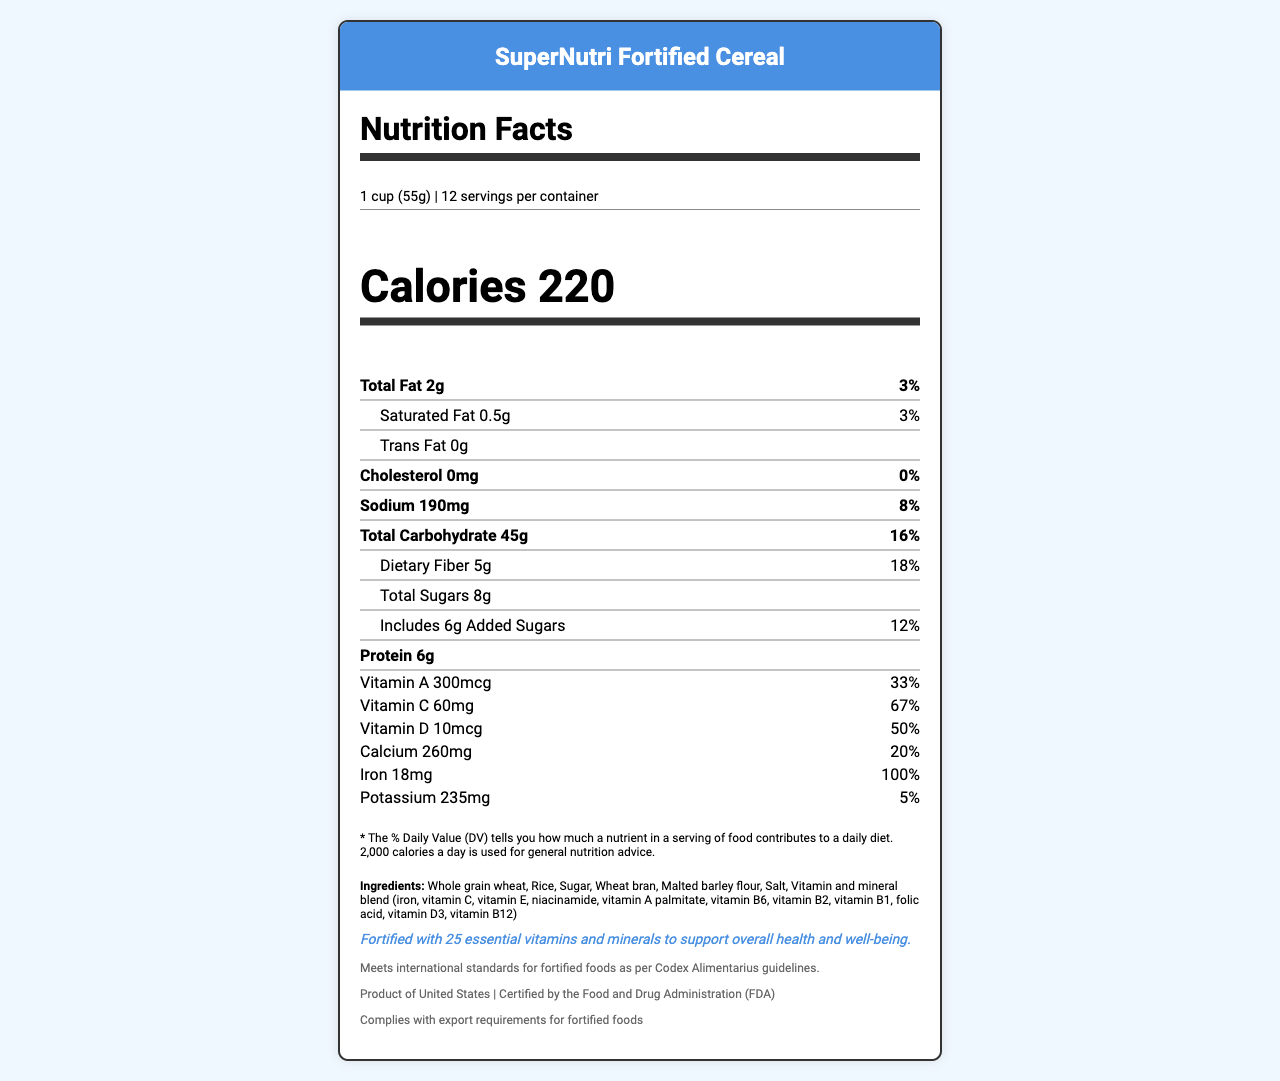what is the serving size? The document specifies the serving size as "1 cup (55g)" in the serving information section.
Answer: 1 cup (55g) how many calories are in one serving? The document lists the calories per serving as 220 in the calories section.
Answer: 220 what is the percentage of daily value for dietary fiber? The document lists the daily value percentage for dietary fiber as 18%.
Answer: 18% what amount of sodium is in one serving? The document specifies the amount of sodium per serving as 190mg.
Answer: 190mg how much iron is in the product, and what is its percent daily value? The document lists the amount of iron as 18mg and the percent daily value as 100%.
Answer: 18mg, 100% what vitamins have a daily value percentage of 100%? The document lists several vitamins with a daily value percentage of 100%: Thiamin (B1), Riboflavin (B2), Niacin (B3), Vitamin B6, Vitamin B12, Folate, Biotin, and Pantothenic Acid.
Answer: Thiamin (B1), Riboflavin (B2), Niacin (B3), Vitamin B6, Vitamin B12, Folate, Biotin, Pantothenic Acid how many servings per container? The document specifies that there are 12 servings per container.
Answer: 12 does the product contain any allergens? The document states that the product contains wheat ingredients and may contain soy and tree nuts.
Answer: Yes what fortification statement is provided? The fortification statement in the document reads: "Fortified with 25 essential vitamins and minerals to support overall health and well-being."
Answer: Fortified with 25 essential vitamins and minerals to support overall health and well-being. what regulatory compliance does the product meet? The document states that the product meets international standards for fortified foods according to Codex Alimentarius guidelines.
Answer: Meets international standards for fortified foods as per Codex Alimentarius guidelines. how much protein is in the product? The document lists the protein content as 6g per serving.
Answer: 6g which vitamin provides 50% of the daily value? A. Vitamin A B. Vitamin C C. Vitamin D D. Vitamin K The document states that Vitamin D provides 50% of the daily value.
Answer: C. Vitamin D what is the serving size option? 1. 55g 2. 1 cup (55g) 3. 220 calories The document specifies the serving size as "1 cup (55g)", which is option 2.
Answer: 2. 1 cup (55g) is the product certified by the FDA? The document indicates that the product is certified by the Food and Drug Administration (FDA).
Answer: Yes summarize the main idea of the document The document represents the Nutrition Facts Label for SuperNutri Fortified Cereal. It enumerates the nutrient amounts per serving, percentages of daily values, allergen information, and regulatory compliance details, emphasizing the product's fortification with numerous vitamins and minerals.
Answer: The document provides comprehensive nutritional information for SuperNutri Fortified Cereal, including calories, macronutrient content, and detailed vitamin and mineral composition with their percentages of daily values. It also includes serving size, allergens, fortification details, and regulatory compliance. what is the manufacturing process of the cereal? The document does not provide any information about the manufacturing process of the cereal.
Answer: Cannot be determined 